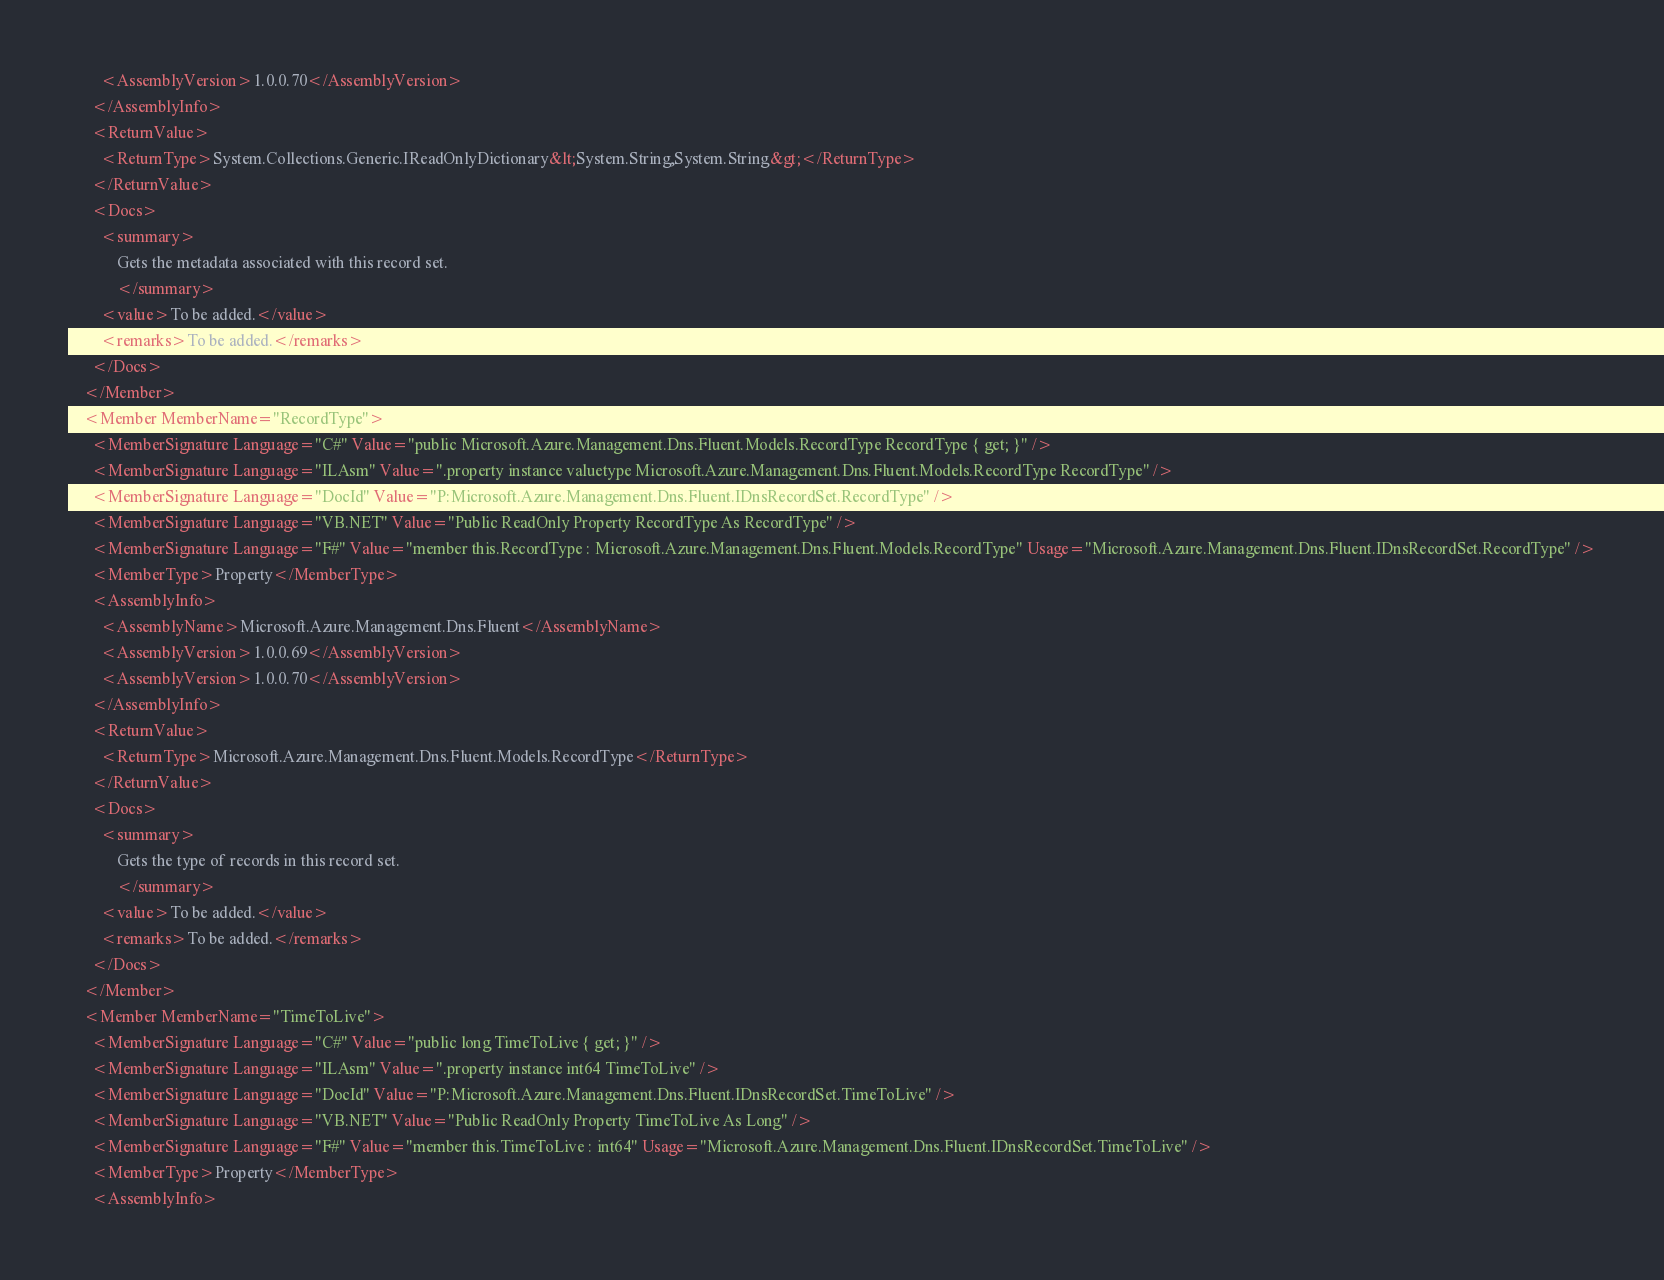<code> <loc_0><loc_0><loc_500><loc_500><_XML_>        <AssemblyVersion>1.0.0.70</AssemblyVersion>
      </AssemblyInfo>
      <ReturnValue>
        <ReturnType>System.Collections.Generic.IReadOnlyDictionary&lt;System.String,System.String&gt;</ReturnType>
      </ReturnValue>
      <Docs>
        <summary>
            Gets the metadata associated with this record set.
            </summary>
        <value>To be added.</value>
        <remarks>To be added.</remarks>
      </Docs>
    </Member>
    <Member MemberName="RecordType">
      <MemberSignature Language="C#" Value="public Microsoft.Azure.Management.Dns.Fluent.Models.RecordType RecordType { get; }" />
      <MemberSignature Language="ILAsm" Value=".property instance valuetype Microsoft.Azure.Management.Dns.Fluent.Models.RecordType RecordType" />
      <MemberSignature Language="DocId" Value="P:Microsoft.Azure.Management.Dns.Fluent.IDnsRecordSet.RecordType" />
      <MemberSignature Language="VB.NET" Value="Public ReadOnly Property RecordType As RecordType" />
      <MemberSignature Language="F#" Value="member this.RecordType : Microsoft.Azure.Management.Dns.Fluent.Models.RecordType" Usage="Microsoft.Azure.Management.Dns.Fluent.IDnsRecordSet.RecordType" />
      <MemberType>Property</MemberType>
      <AssemblyInfo>
        <AssemblyName>Microsoft.Azure.Management.Dns.Fluent</AssemblyName>
        <AssemblyVersion>1.0.0.69</AssemblyVersion>
        <AssemblyVersion>1.0.0.70</AssemblyVersion>
      </AssemblyInfo>
      <ReturnValue>
        <ReturnType>Microsoft.Azure.Management.Dns.Fluent.Models.RecordType</ReturnType>
      </ReturnValue>
      <Docs>
        <summary>
            Gets the type of records in this record set.
            </summary>
        <value>To be added.</value>
        <remarks>To be added.</remarks>
      </Docs>
    </Member>
    <Member MemberName="TimeToLive">
      <MemberSignature Language="C#" Value="public long TimeToLive { get; }" />
      <MemberSignature Language="ILAsm" Value=".property instance int64 TimeToLive" />
      <MemberSignature Language="DocId" Value="P:Microsoft.Azure.Management.Dns.Fluent.IDnsRecordSet.TimeToLive" />
      <MemberSignature Language="VB.NET" Value="Public ReadOnly Property TimeToLive As Long" />
      <MemberSignature Language="F#" Value="member this.TimeToLive : int64" Usage="Microsoft.Azure.Management.Dns.Fluent.IDnsRecordSet.TimeToLive" />
      <MemberType>Property</MemberType>
      <AssemblyInfo></code> 